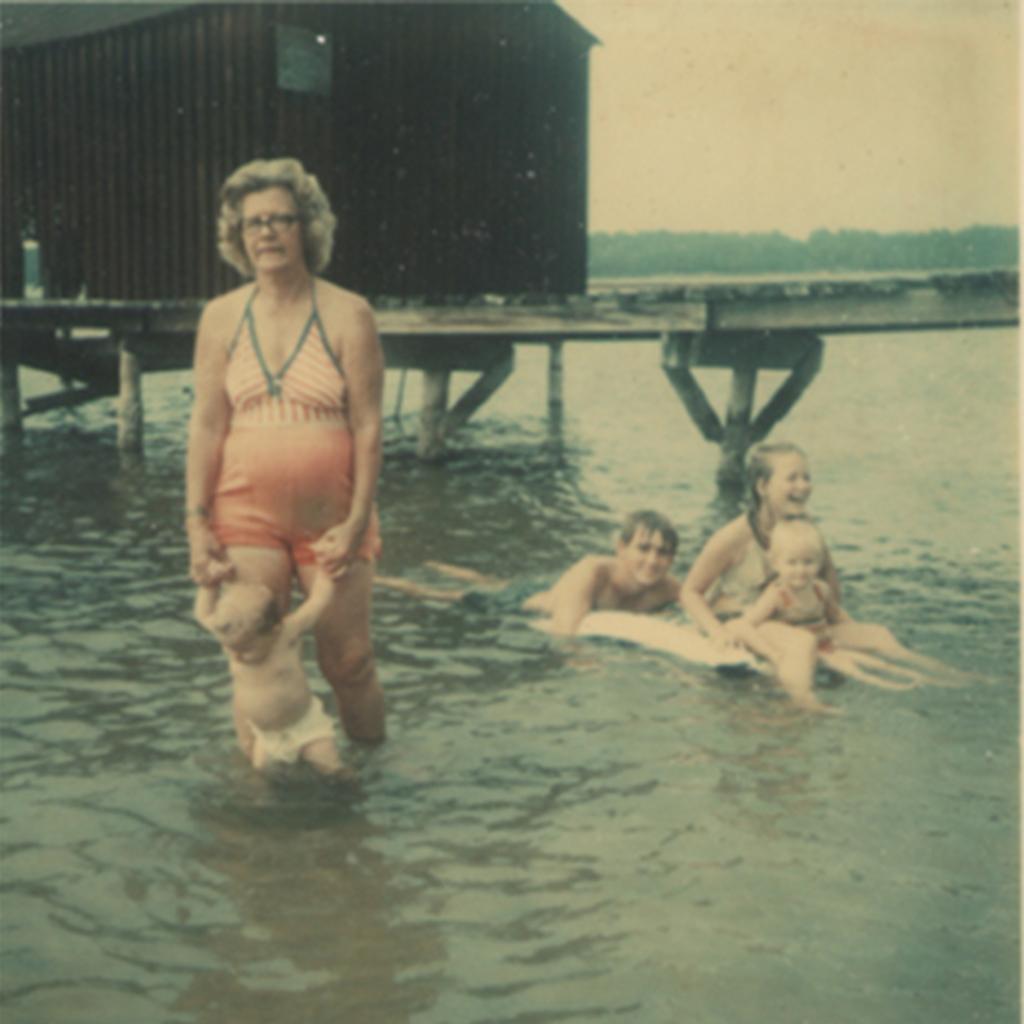Could you give a brief overview of what you see in this image? In this image we can see a woman wearing the glasses and we can also see the kids in the water. In the background we can see the bridge with the roof house. We can also see the trees. Sky is also visible. 